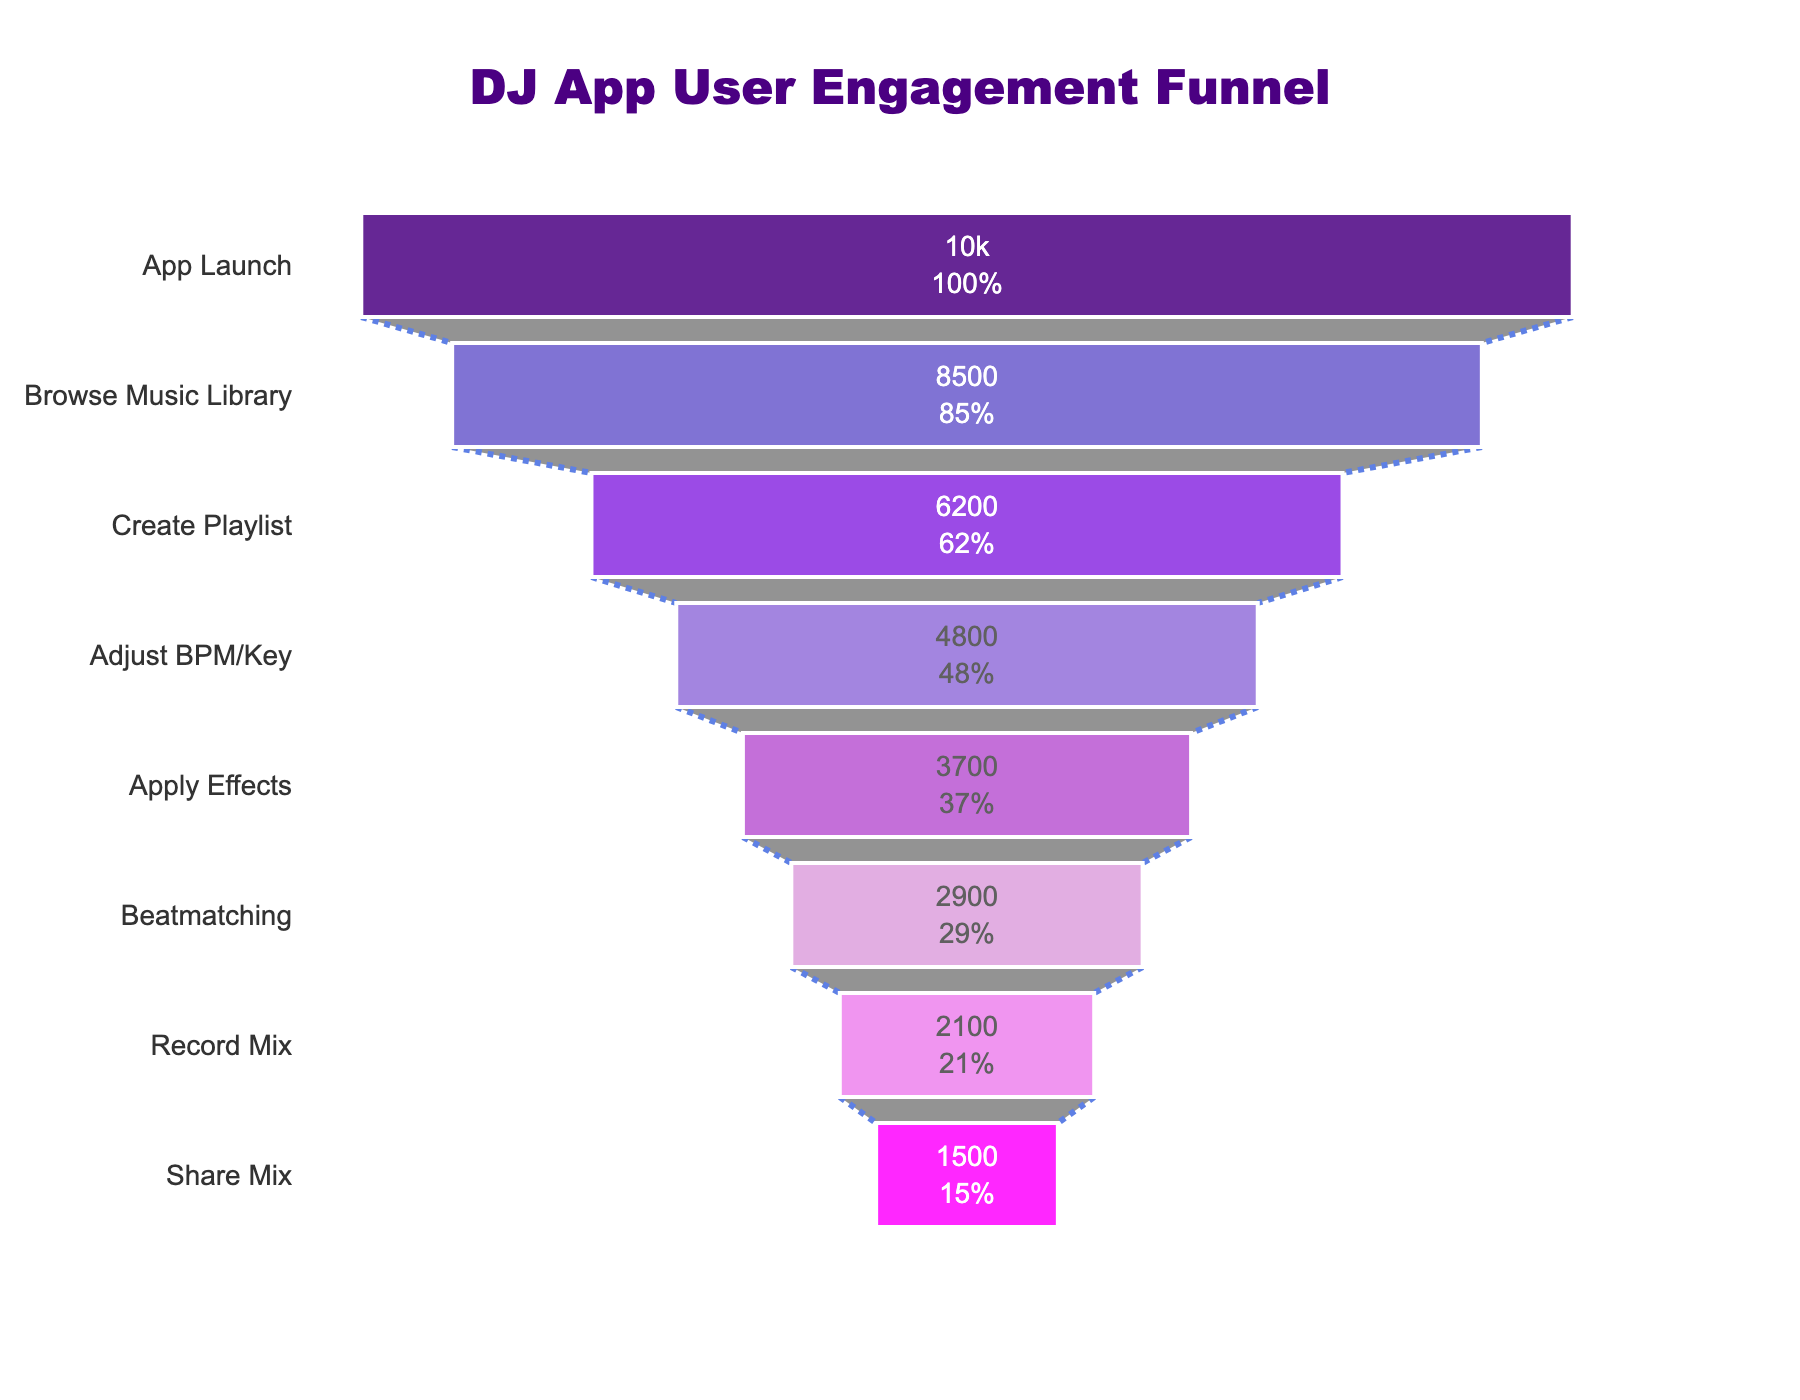Which stage has the highest number of users? By examining the funnel chart, the highest number of users is shown at the top stage. The top stage in the funnel is "App Launch".
Answer: App Launch Which stage has the lowest number of users? By looking at the bottom of the funnel chart, the stage with the lowest number of users is "Share Mix"
Answer: Share Mix How many users drop off from "Browse Music Library" to "Create Playlist"? From the funnel chart, "Browse Music Library" has 8500 users and "Create Playlist" has 6200 users. The difference is 8500 - 6200.
Answer: 2300 What percentage of users move from "Create Playlist" to "Adjust BPM/Key"? "Create Playlist" has 6200 users and "Adjust BPM/Key" has 4800 users. The percentage is (4800 / 6200) * 100.
Answer: 77.42% What is the total number of users that proceed past the "Adjust BPM/Key" stage? From the chart, summing up the users from "Apply Effects", "Beatmatching", "Record Mix", and "Share Mix" gives 3700 + 2900 + 2100 + 1500. Sum: 10200.
Answer: 10200 What is the percentage drop from "Beatmatching" to "Record Mix"? From the funnel, "Beatmatching" has 2900 users and "Record Mix" has 2100 users. The percentage drop is ((2900 - 2100) / 2900) * 100.
Answer: 27.59% How does the number of users at "Record Mix" compare to those at "Browse Music Library"? By comparing the chart, "Record Mix" has 2100 users and "Browse Music Library" has 8500 users; 2100 is much lower than 8500.
Answer: Much lower What is the difference in user count between the "Apply Effects" and "Beatmatching" stages? "Apply Effects" has 3700 users, and "Beatmatching" has 2900 users. The difference is 3700 - 2900.
Answer: 800 What is the percentage decrease from "App Launch" to "Share Mix"? "App Launch" has 10000 users and "Share Mix" has 1500 users. The percentage decrease is ((10000 - 1500) / 10000) * 100.
Answer: 85% How many sections are represented in the funnel chart? By counting the number of unique stages in the funnel chart, there are 8 stages total.
Answer: 8 